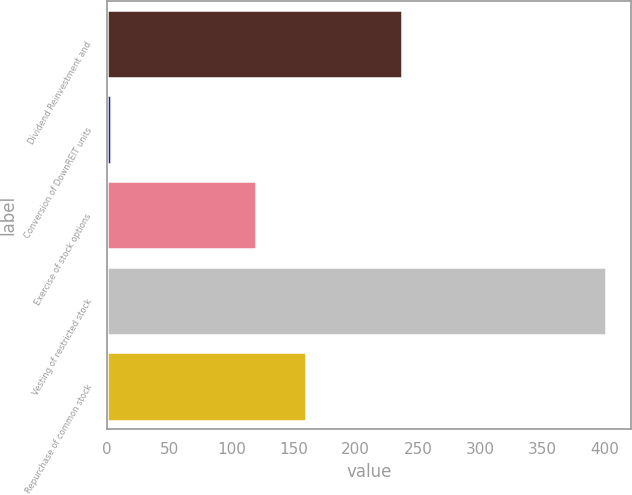Convert chart to OTSL. <chart><loc_0><loc_0><loc_500><loc_500><bar_chart><fcel>Dividend Reinvestment and<fcel>Conversion of DownREIT units<fcel>Exercise of stock options<fcel>Vesting of restricted stock<fcel>Repurchase of common stock<nl><fcel>237<fcel>3<fcel>120<fcel>401<fcel>159.8<nl></chart> 